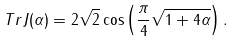Convert formula to latex. <formula><loc_0><loc_0><loc_500><loc_500>T r J ( \alpha ) = 2 \sqrt { 2 } \cos \left ( \frac { \pi } { 4 } \sqrt { 1 + 4 \alpha } \right ) .</formula> 